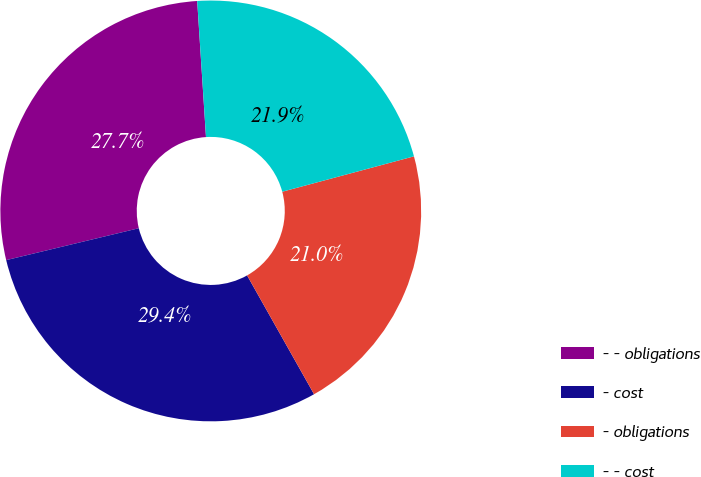Convert chart to OTSL. <chart><loc_0><loc_0><loc_500><loc_500><pie_chart><fcel>- - obligations<fcel>- cost<fcel>- obligations<fcel>- - cost<nl><fcel>27.73%<fcel>29.41%<fcel>21.01%<fcel>21.85%<nl></chart> 